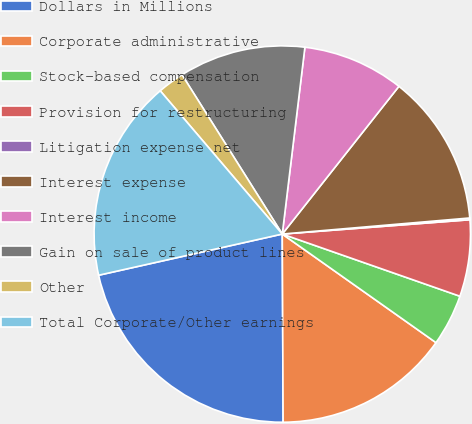<chart> <loc_0><loc_0><loc_500><loc_500><pie_chart><fcel>Dollars in Millions<fcel>Corporate administrative<fcel>Stock-based compensation<fcel>Provision for restructuring<fcel>Litigation expense net<fcel>Interest expense<fcel>Interest income<fcel>Gain on sale of product lines<fcel>Other<fcel>Total Corporate/Other earnings<nl><fcel>21.56%<fcel>15.14%<fcel>4.43%<fcel>6.57%<fcel>0.15%<fcel>13.0%<fcel>8.72%<fcel>10.86%<fcel>2.29%<fcel>17.28%<nl></chart> 